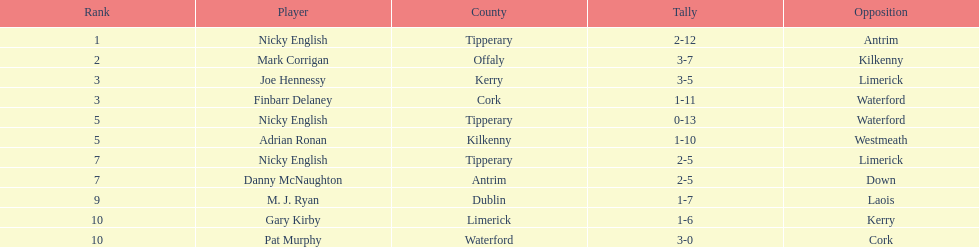Give me the full table as a dictionary. {'header': ['Rank', 'Player', 'County', 'Tally', 'Opposition'], 'rows': [['1', 'Nicky English', 'Tipperary', '2-12', 'Antrim'], ['2', 'Mark Corrigan', 'Offaly', '3-7', 'Kilkenny'], ['3', 'Joe Hennessy', 'Kerry', '3-5', 'Limerick'], ['3', 'Finbarr Delaney', 'Cork', '1-11', 'Waterford'], ['5', 'Nicky English', 'Tipperary', '0-13', 'Waterford'], ['5', 'Adrian Ronan', 'Kilkenny', '1-10', 'Westmeath'], ['7', 'Nicky English', 'Tipperary', '2-5', 'Limerick'], ['7', 'Danny McNaughton', 'Antrim', '2-5', 'Down'], ['9', 'M. J. Ryan', 'Dublin', '1-7', 'Laois'], ['10', 'Gary Kirby', 'Limerick', '1-6', 'Kerry'], ['10', 'Pat Murphy', 'Waterford', '3-0', 'Cork']]} Joe hennessy and finbarr delaney both scored how many points? 14. 